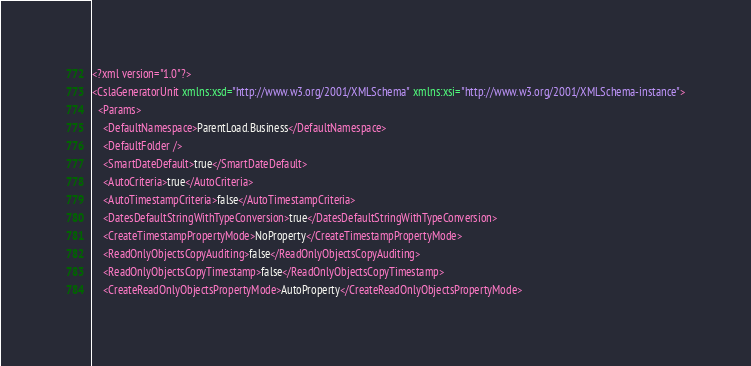Convert code to text. <code><loc_0><loc_0><loc_500><loc_500><_XML_><?xml version="1.0"?>
<CslaGeneratorUnit xmlns:xsd="http://www.w3.org/2001/XMLSchema" xmlns:xsi="http://www.w3.org/2001/XMLSchema-instance">
  <Params>
    <DefaultNamespace>ParentLoad.Business</DefaultNamespace>
    <DefaultFolder />
    <SmartDateDefault>true</SmartDateDefault>
    <AutoCriteria>true</AutoCriteria>
    <AutoTimestampCriteria>false</AutoTimestampCriteria>
    <DatesDefaultStringWithTypeConversion>true</DatesDefaultStringWithTypeConversion>
    <CreateTimestampPropertyMode>NoProperty</CreateTimestampPropertyMode>
    <ReadOnlyObjectsCopyAuditing>false</ReadOnlyObjectsCopyAuditing>
    <ReadOnlyObjectsCopyTimestamp>false</ReadOnlyObjectsCopyTimestamp>
    <CreateReadOnlyObjectsPropertyMode>AutoProperty</CreateReadOnlyObjectsPropertyMode></code> 